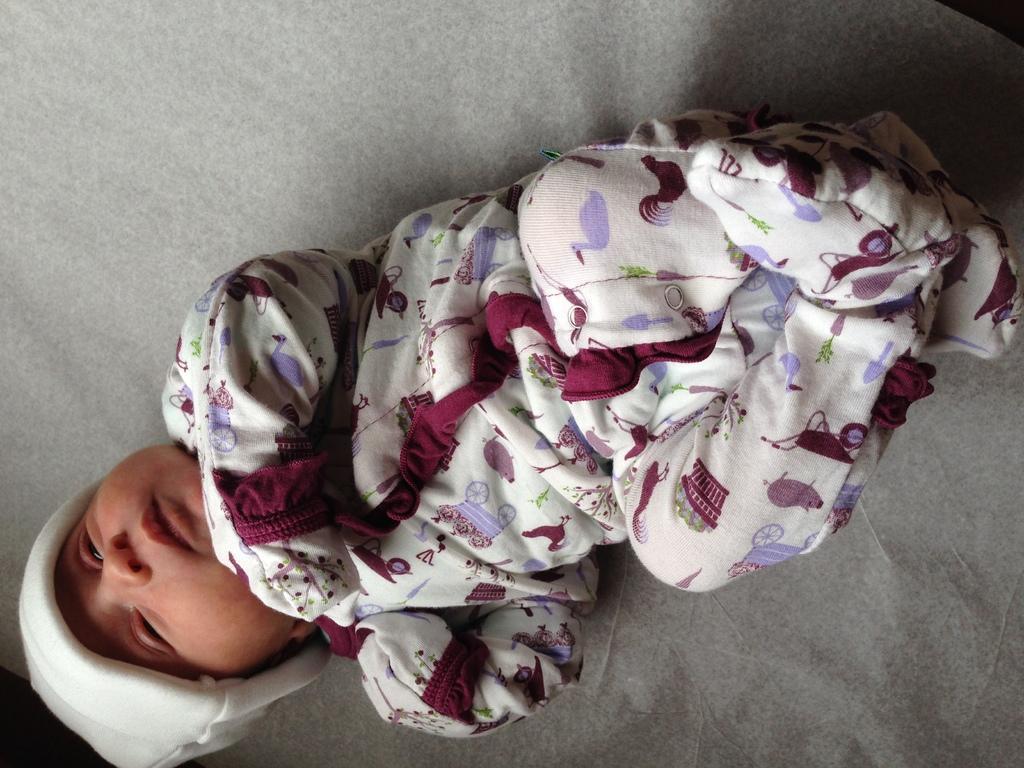How would you summarize this image in a sentence or two? In this picture we can see baby lying on a grey surface. 